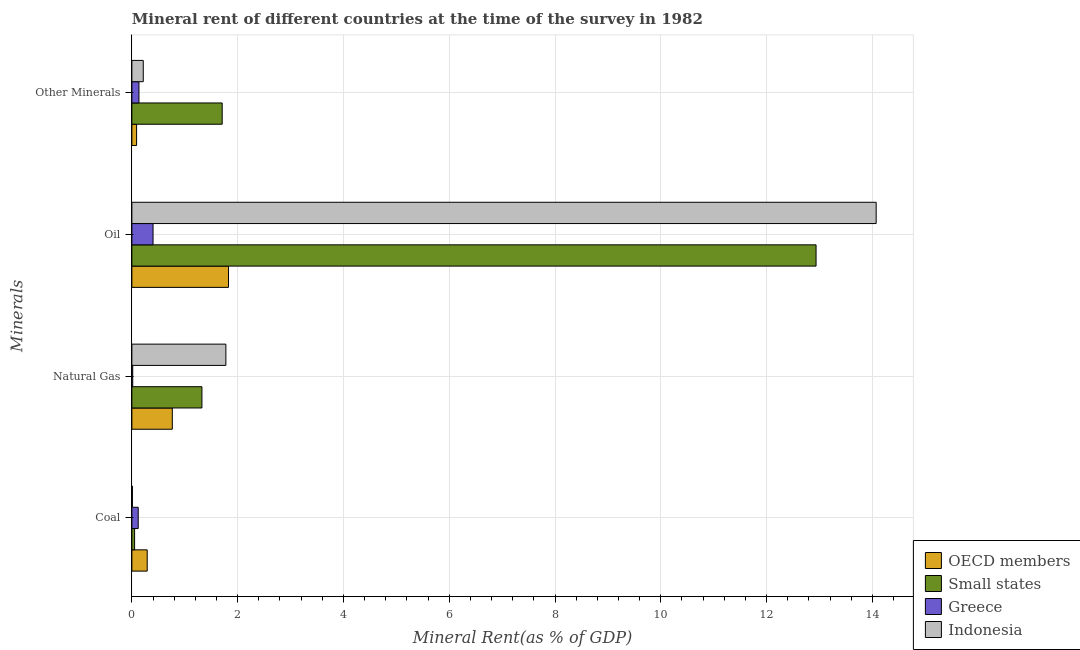How many different coloured bars are there?
Offer a very short reply. 4. Are the number of bars on each tick of the Y-axis equal?
Give a very brief answer. Yes. What is the label of the 4th group of bars from the top?
Your answer should be very brief. Coal. What is the oil rent in Indonesia?
Your response must be concise. 14.07. Across all countries, what is the maximum natural gas rent?
Offer a terse response. 1.78. Across all countries, what is the minimum oil rent?
Keep it short and to the point. 0.4. In which country was the oil rent maximum?
Offer a very short reply. Indonesia. In which country was the natural gas rent minimum?
Ensure brevity in your answer.  Greece. What is the total oil rent in the graph?
Keep it short and to the point. 29.23. What is the difference between the natural gas rent in Greece and that in Indonesia?
Offer a very short reply. -1.76. What is the difference between the oil rent in Indonesia and the  rent of other minerals in Small states?
Provide a succinct answer. 12.36. What is the average oil rent per country?
Provide a short and direct response. 7.31. What is the difference between the oil rent and  rent of other minerals in OECD members?
Make the answer very short. 1.74. What is the ratio of the coal rent in Indonesia to that in OECD members?
Your answer should be very brief. 0.04. Is the oil rent in Indonesia less than that in OECD members?
Ensure brevity in your answer.  No. What is the difference between the highest and the second highest natural gas rent?
Offer a terse response. 0.45. What is the difference between the highest and the lowest coal rent?
Provide a short and direct response. 0.28. What does the 3rd bar from the top in Other Minerals represents?
Your answer should be compact. Small states. What does the 3rd bar from the bottom in Other Minerals represents?
Offer a terse response. Greece. Is it the case that in every country, the sum of the coal rent and natural gas rent is greater than the oil rent?
Give a very brief answer. No. How many countries are there in the graph?
Your answer should be very brief. 4. Does the graph contain grids?
Offer a very short reply. Yes. Where does the legend appear in the graph?
Offer a terse response. Bottom right. How many legend labels are there?
Give a very brief answer. 4. How are the legend labels stacked?
Make the answer very short. Vertical. What is the title of the graph?
Offer a very short reply. Mineral rent of different countries at the time of the survey in 1982. What is the label or title of the X-axis?
Make the answer very short. Mineral Rent(as % of GDP). What is the label or title of the Y-axis?
Your answer should be very brief. Minerals. What is the Mineral Rent(as % of GDP) in OECD members in Coal?
Your response must be concise. 0.29. What is the Mineral Rent(as % of GDP) of Small states in Coal?
Offer a terse response. 0.05. What is the Mineral Rent(as % of GDP) of Greece in Coal?
Provide a succinct answer. 0.12. What is the Mineral Rent(as % of GDP) of Indonesia in Coal?
Ensure brevity in your answer.  0.01. What is the Mineral Rent(as % of GDP) of OECD members in Natural Gas?
Your response must be concise. 0.76. What is the Mineral Rent(as % of GDP) in Small states in Natural Gas?
Make the answer very short. 1.32. What is the Mineral Rent(as % of GDP) of Greece in Natural Gas?
Your answer should be compact. 0.02. What is the Mineral Rent(as % of GDP) in Indonesia in Natural Gas?
Provide a short and direct response. 1.78. What is the Mineral Rent(as % of GDP) of OECD members in Oil?
Keep it short and to the point. 1.83. What is the Mineral Rent(as % of GDP) of Small states in Oil?
Offer a very short reply. 12.94. What is the Mineral Rent(as % of GDP) in Greece in Oil?
Your answer should be very brief. 0.4. What is the Mineral Rent(as % of GDP) in Indonesia in Oil?
Make the answer very short. 14.07. What is the Mineral Rent(as % of GDP) in OECD members in Other Minerals?
Provide a short and direct response. 0.09. What is the Mineral Rent(as % of GDP) in Small states in Other Minerals?
Ensure brevity in your answer.  1.71. What is the Mineral Rent(as % of GDP) in Greece in Other Minerals?
Your answer should be compact. 0.13. What is the Mineral Rent(as % of GDP) in Indonesia in Other Minerals?
Your answer should be very brief. 0.22. Across all Minerals, what is the maximum Mineral Rent(as % of GDP) of OECD members?
Ensure brevity in your answer.  1.83. Across all Minerals, what is the maximum Mineral Rent(as % of GDP) in Small states?
Give a very brief answer. 12.94. Across all Minerals, what is the maximum Mineral Rent(as % of GDP) in Greece?
Offer a terse response. 0.4. Across all Minerals, what is the maximum Mineral Rent(as % of GDP) of Indonesia?
Provide a succinct answer. 14.07. Across all Minerals, what is the minimum Mineral Rent(as % of GDP) of OECD members?
Offer a terse response. 0.09. Across all Minerals, what is the minimum Mineral Rent(as % of GDP) of Small states?
Make the answer very short. 0.05. Across all Minerals, what is the minimum Mineral Rent(as % of GDP) in Greece?
Give a very brief answer. 0.02. Across all Minerals, what is the minimum Mineral Rent(as % of GDP) in Indonesia?
Make the answer very short. 0.01. What is the total Mineral Rent(as % of GDP) in OECD members in the graph?
Provide a succinct answer. 2.97. What is the total Mineral Rent(as % of GDP) of Small states in the graph?
Ensure brevity in your answer.  16.02. What is the total Mineral Rent(as % of GDP) of Greece in the graph?
Provide a succinct answer. 0.67. What is the total Mineral Rent(as % of GDP) of Indonesia in the graph?
Provide a short and direct response. 16.07. What is the difference between the Mineral Rent(as % of GDP) in OECD members in Coal and that in Natural Gas?
Give a very brief answer. -0.47. What is the difference between the Mineral Rent(as % of GDP) of Small states in Coal and that in Natural Gas?
Provide a short and direct response. -1.27. What is the difference between the Mineral Rent(as % of GDP) of Greece in Coal and that in Natural Gas?
Offer a very short reply. 0.1. What is the difference between the Mineral Rent(as % of GDP) in Indonesia in Coal and that in Natural Gas?
Offer a terse response. -1.77. What is the difference between the Mineral Rent(as % of GDP) in OECD members in Coal and that in Oil?
Ensure brevity in your answer.  -1.54. What is the difference between the Mineral Rent(as % of GDP) of Small states in Coal and that in Oil?
Make the answer very short. -12.88. What is the difference between the Mineral Rent(as % of GDP) in Greece in Coal and that in Oil?
Your answer should be compact. -0.28. What is the difference between the Mineral Rent(as % of GDP) in Indonesia in Coal and that in Oil?
Your answer should be compact. -14.06. What is the difference between the Mineral Rent(as % of GDP) of OECD members in Coal and that in Other Minerals?
Give a very brief answer. 0.2. What is the difference between the Mineral Rent(as % of GDP) of Small states in Coal and that in Other Minerals?
Ensure brevity in your answer.  -1.66. What is the difference between the Mineral Rent(as % of GDP) in Greece in Coal and that in Other Minerals?
Keep it short and to the point. -0.01. What is the difference between the Mineral Rent(as % of GDP) in Indonesia in Coal and that in Other Minerals?
Make the answer very short. -0.2. What is the difference between the Mineral Rent(as % of GDP) of OECD members in Natural Gas and that in Oil?
Provide a short and direct response. -1.06. What is the difference between the Mineral Rent(as % of GDP) in Small states in Natural Gas and that in Oil?
Ensure brevity in your answer.  -11.61. What is the difference between the Mineral Rent(as % of GDP) of Greece in Natural Gas and that in Oil?
Make the answer very short. -0.38. What is the difference between the Mineral Rent(as % of GDP) in Indonesia in Natural Gas and that in Oil?
Your answer should be very brief. -12.29. What is the difference between the Mineral Rent(as % of GDP) of OECD members in Natural Gas and that in Other Minerals?
Your response must be concise. 0.68. What is the difference between the Mineral Rent(as % of GDP) in Small states in Natural Gas and that in Other Minerals?
Provide a short and direct response. -0.38. What is the difference between the Mineral Rent(as % of GDP) in Greece in Natural Gas and that in Other Minerals?
Give a very brief answer. -0.12. What is the difference between the Mineral Rent(as % of GDP) of Indonesia in Natural Gas and that in Other Minerals?
Give a very brief answer. 1.56. What is the difference between the Mineral Rent(as % of GDP) of OECD members in Oil and that in Other Minerals?
Your response must be concise. 1.74. What is the difference between the Mineral Rent(as % of GDP) of Small states in Oil and that in Other Minerals?
Ensure brevity in your answer.  11.23. What is the difference between the Mineral Rent(as % of GDP) of Greece in Oil and that in Other Minerals?
Give a very brief answer. 0.27. What is the difference between the Mineral Rent(as % of GDP) of Indonesia in Oil and that in Other Minerals?
Make the answer very short. 13.86. What is the difference between the Mineral Rent(as % of GDP) in OECD members in Coal and the Mineral Rent(as % of GDP) in Small states in Natural Gas?
Your response must be concise. -1.03. What is the difference between the Mineral Rent(as % of GDP) in OECD members in Coal and the Mineral Rent(as % of GDP) in Greece in Natural Gas?
Keep it short and to the point. 0.27. What is the difference between the Mineral Rent(as % of GDP) of OECD members in Coal and the Mineral Rent(as % of GDP) of Indonesia in Natural Gas?
Offer a very short reply. -1.49. What is the difference between the Mineral Rent(as % of GDP) of Small states in Coal and the Mineral Rent(as % of GDP) of Greece in Natural Gas?
Make the answer very short. 0.04. What is the difference between the Mineral Rent(as % of GDP) in Small states in Coal and the Mineral Rent(as % of GDP) in Indonesia in Natural Gas?
Your answer should be compact. -1.73. What is the difference between the Mineral Rent(as % of GDP) in Greece in Coal and the Mineral Rent(as % of GDP) in Indonesia in Natural Gas?
Your answer should be compact. -1.66. What is the difference between the Mineral Rent(as % of GDP) in OECD members in Coal and the Mineral Rent(as % of GDP) in Small states in Oil?
Keep it short and to the point. -12.65. What is the difference between the Mineral Rent(as % of GDP) of OECD members in Coal and the Mineral Rent(as % of GDP) of Greece in Oil?
Your response must be concise. -0.11. What is the difference between the Mineral Rent(as % of GDP) of OECD members in Coal and the Mineral Rent(as % of GDP) of Indonesia in Oil?
Make the answer very short. -13.78. What is the difference between the Mineral Rent(as % of GDP) in Small states in Coal and the Mineral Rent(as % of GDP) in Greece in Oil?
Keep it short and to the point. -0.35. What is the difference between the Mineral Rent(as % of GDP) in Small states in Coal and the Mineral Rent(as % of GDP) in Indonesia in Oil?
Your response must be concise. -14.02. What is the difference between the Mineral Rent(as % of GDP) of Greece in Coal and the Mineral Rent(as % of GDP) of Indonesia in Oil?
Keep it short and to the point. -13.95. What is the difference between the Mineral Rent(as % of GDP) of OECD members in Coal and the Mineral Rent(as % of GDP) of Small states in Other Minerals?
Your answer should be very brief. -1.42. What is the difference between the Mineral Rent(as % of GDP) in OECD members in Coal and the Mineral Rent(as % of GDP) in Greece in Other Minerals?
Offer a terse response. 0.16. What is the difference between the Mineral Rent(as % of GDP) of OECD members in Coal and the Mineral Rent(as % of GDP) of Indonesia in Other Minerals?
Offer a terse response. 0.07. What is the difference between the Mineral Rent(as % of GDP) in Small states in Coal and the Mineral Rent(as % of GDP) in Greece in Other Minerals?
Provide a short and direct response. -0.08. What is the difference between the Mineral Rent(as % of GDP) of Small states in Coal and the Mineral Rent(as % of GDP) of Indonesia in Other Minerals?
Ensure brevity in your answer.  -0.16. What is the difference between the Mineral Rent(as % of GDP) of Greece in Coal and the Mineral Rent(as % of GDP) of Indonesia in Other Minerals?
Provide a succinct answer. -0.1. What is the difference between the Mineral Rent(as % of GDP) in OECD members in Natural Gas and the Mineral Rent(as % of GDP) in Small states in Oil?
Your response must be concise. -12.17. What is the difference between the Mineral Rent(as % of GDP) of OECD members in Natural Gas and the Mineral Rent(as % of GDP) of Greece in Oil?
Give a very brief answer. 0.36. What is the difference between the Mineral Rent(as % of GDP) in OECD members in Natural Gas and the Mineral Rent(as % of GDP) in Indonesia in Oil?
Provide a short and direct response. -13.31. What is the difference between the Mineral Rent(as % of GDP) of Small states in Natural Gas and the Mineral Rent(as % of GDP) of Greece in Oil?
Offer a very short reply. 0.92. What is the difference between the Mineral Rent(as % of GDP) of Small states in Natural Gas and the Mineral Rent(as % of GDP) of Indonesia in Oil?
Ensure brevity in your answer.  -12.75. What is the difference between the Mineral Rent(as % of GDP) of Greece in Natural Gas and the Mineral Rent(as % of GDP) of Indonesia in Oil?
Your answer should be very brief. -14.06. What is the difference between the Mineral Rent(as % of GDP) of OECD members in Natural Gas and the Mineral Rent(as % of GDP) of Small states in Other Minerals?
Provide a short and direct response. -0.94. What is the difference between the Mineral Rent(as % of GDP) in OECD members in Natural Gas and the Mineral Rent(as % of GDP) in Greece in Other Minerals?
Give a very brief answer. 0.63. What is the difference between the Mineral Rent(as % of GDP) of OECD members in Natural Gas and the Mineral Rent(as % of GDP) of Indonesia in Other Minerals?
Your answer should be very brief. 0.55. What is the difference between the Mineral Rent(as % of GDP) of Small states in Natural Gas and the Mineral Rent(as % of GDP) of Greece in Other Minerals?
Give a very brief answer. 1.19. What is the difference between the Mineral Rent(as % of GDP) of Small states in Natural Gas and the Mineral Rent(as % of GDP) of Indonesia in Other Minerals?
Your response must be concise. 1.11. What is the difference between the Mineral Rent(as % of GDP) in Greece in Natural Gas and the Mineral Rent(as % of GDP) in Indonesia in Other Minerals?
Offer a terse response. -0.2. What is the difference between the Mineral Rent(as % of GDP) of OECD members in Oil and the Mineral Rent(as % of GDP) of Small states in Other Minerals?
Ensure brevity in your answer.  0.12. What is the difference between the Mineral Rent(as % of GDP) in OECD members in Oil and the Mineral Rent(as % of GDP) in Greece in Other Minerals?
Provide a short and direct response. 1.69. What is the difference between the Mineral Rent(as % of GDP) in OECD members in Oil and the Mineral Rent(as % of GDP) in Indonesia in Other Minerals?
Provide a short and direct response. 1.61. What is the difference between the Mineral Rent(as % of GDP) in Small states in Oil and the Mineral Rent(as % of GDP) in Greece in Other Minerals?
Ensure brevity in your answer.  12.8. What is the difference between the Mineral Rent(as % of GDP) in Small states in Oil and the Mineral Rent(as % of GDP) in Indonesia in Other Minerals?
Make the answer very short. 12.72. What is the difference between the Mineral Rent(as % of GDP) in Greece in Oil and the Mineral Rent(as % of GDP) in Indonesia in Other Minerals?
Provide a short and direct response. 0.18. What is the average Mineral Rent(as % of GDP) of OECD members per Minerals?
Make the answer very short. 0.74. What is the average Mineral Rent(as % of GDP) of Small states per Minerals?
Your response must be concise. 4. What is the average Mineral Rent(as % of GDP) of Greece per Minerals?
Your response must be concise. 0.17. What is the average Mineral Rent(as % of GDP) of Indonesia per Minerals?
Offer a very short reply. 4.02. What is the difference between the Mineral Rent(as % of GDP) of OECD members and Mineral Rent(as % of GDP) of Small states in Coal?
Give a very brief answer. 0.24. What is the difference between the Mineral Rent(as % of GDP) in OECD members and Mineral Rent(as % of GDP) in Greece in Coal?
Your answer should be compact. 0.17. What is the difference between the Mineral Rent(as % of GDP) of OECD members and Mineral Rent(as % of GDP) of Indonesia in Coal?
Provide a succinct answer. 0.28. What is the difference between the Mineral Rent(as % of GDP) in Small states and Mineral Rent(as % of GDP) in Greece in Coal?
Your response must be concise. -0.07. What is the difference between the Mineral Rent(as % of GDP) in Small states and Mineral Rent(as % of GDP) in Indonesia in Coal?
Your response must be concise. 0.04. What is the difference between the Mineral Rent(as % of GDP) in Greece and Mineral Rent(as % of GDP) in Indonesia in Coal?
Offer a terse response. 0.11. What is the difference between the Mineral Rent(as % of GDP) of OECD members and Mineral Rent(as % of GDP) of Small states in Natural Gas?
Your answer should be compact. -0.56. What is the difference between the Mineral Rent(as % of GDP) in OECD members and Mineral Rent(as % of GDP) in Greece in Natural Gas?
Offer a very short reply. 0.75. What is the difference between the Mineral Rent(as % of GDP) in OECD members and Mineral Rent(as % of GDP) in Indonesia in Natural Gas?
Keep it short and to the point. -1.01. What is the difference between the Mineral Rent(as % of GDP) in Small states and Mineral Rent(as % of GDP) in Greece in Natural Gas?
Provide a succinct answer. 1.31. What is the difference between the Mineral Rent(as % of GDP) of Small states and Mineral Rent(as % of GDP) of Indonesia in Natural Gas?
Provide a short and direct response. -0.45. What is the difference between the Mineral Rent(as % of GDP) of Greece and Mineral Rent(as % of GDP) of Indonesia in Natural Gas?
Offer a very short reply. -1.76. What is the difference between the Mineral Rent(as % of GDP) of OECD members and Mineral Rent(as % of GDP) of Small states in Oil?
Ensure brevity in your answer.  -11.11. What is the difference between the Mineral Rent(as % of GDP) in OECD members and Mineral Rent(as % of GDP) in Greece in Oil?
Keep it short and to the point. 1.43. What is the difference between the Mineral Rent(as % of GDP) of OECD members and Mineral Rent(as % of GDP) of Indonesia in Oil?
Your response must be concise. -12.24. What is the difference between the Mineral Rent(as % of GDP) in Small states and Mineral Rent(as % of GDP) in Greece in Oil?
Your answer should be very brief. 12.53. What is the difference between the Mineral Rent(as % of GDP) in Small states and Mineral Rent(as % of GDP) in Indonesia in Oil?
Your response must be concise. -1.14. What is the difference between the Mineral Rent(as % of GDP) in Greece and Mineral Rent(as % of GDP) in Indonesia in Oil?
Keep it short and to the point. -13.67. What is the difference between the Mineral Rent(as % of GDP) in OECD members and Mineral Rent(as % of GDP) in Small states in Other Minerals?
Offer a terse response. -1.62. What is the difference between the Mineral Rent(as % of GDP) of OECD members and Mineral Rent(as % of GDP) of Greece in Other Minerals?
Offer a very short reply. -0.04. What is the difference between the Mineral Rent(as % of GDP) in OECD members and Mineral Rent(as % of GDP) in Indonesia in Other Minerals?
Your response must be concise. -0.13. What is the difference between the Mineral Rent(as % of GDP) of Small states and Mineral Rent(as % of GDP) of Greece in Other Minerals?
Keep it short and to the point. 1.57. What is the difference between the Mineral Rent(as % of GDP) of Small states and Mineral Rent(as % of GDP) of Indonesia in Other Minerals?
Make the answer very short. 1.49. What is the difference between the Mineral Rent(as % of GDP) of Greece and Mineral Rent(as % of GDP) of Indonesia in Other Minerals?
Offer a terse response. -0.08. What is the ratio of the Mineral Rent(as % of GDP) of OECD members in Coal to that in Natural Gas?
Your answer should be very brief. 0.38. What is the ratio of the Mineral Rent(as % of GDP) of Small states in Coal to that in Natural Gas?
Your response must be concise. 0.04. What is the ratio of the Mineral Rent(as % of GDP) of Greece in Coal to that in Natural Gas?
Your answer should be very brief. 7.58. What is the ratio of the Mineral Rent(as % of GDP) of Indonesia in Coal to that in Natural Gas?
Keep it short and to the point. 0.01. What is the ratio of the Mineral Rent(as % of GDP) in OECD members in Coal to that in Oil?
Your response must be concise. 0.16. What is the ratio of the Mineral Rent(as % of GDP) in Small states in Coal to that in Oil?
Offer a terse response. 0. What is the ratio of the Mineral Rent(as % of GDP) in Greece in Coal to that in Oil?
Give a very brief answer. 0.3. What is the ratio of the Mineral Rent(as % of GDP) in Indonesia in Coal to that in Oil?
Ensure brevity in your answer.  0. What is the ratio of the Mineral Rent(as % of GDP) in OECD members in Coal to that in Other Minerals?
Offer a very short reply. 3.25. What is the ratio of the Mineral Rent(as % of GDP) of Small states in Coal to that in Other Minerals?
Make the answer very short. 0.03. What is the ratio of the Mineral Rent(as % of GDP) of Greece in Coal to that in Other Minerals?
Keep it short and to the point. 0.9. What is the ratio of the Mineral Rent(as % of GDP) of Indonesia in Coal to that in Other Minerals?
Provide a short and direct response. 0.05. What is the ratio of the Mineral Rent(as % of GDP) in OECD members in Natural Gas to that in Oil?
Your answer should be very brief. 0.42. What is the ratio of the Mineral Rent(as % of GDP) of Small states in Natural Gas to that in Oil?
Give a very brief answer. 0.1. What is the ratio of the Mineral Rent(as % of GDP) of Greece in Natural Gas to that in Oil?
Provide a short and direct response. 0.04. What is the ratio of the Mineral Rent(as % of GDP) in Indonesia in Natural Gas to that in Oil?
Your response must be concise. 0.13. What is the ratio of the Mineral Rent(as % of GDP) of OECD members in Natural Gas to that in Other Minerals?
Give a very brief answer. 8.58. What is the ratio of the Mineral Rent(as % of GDP) of Small states in Natural Gas to that in Other Minerals?
Offer a terse response. 0.78. What is the ratio of the Mineral Rent(as % of GDP) in Greece in Natural Gas to that in Other Minerals?
Give a very brief answer. 0.12. What is the ratio of the Mineral Rent(as % of GDP) of Indonesia in Natural Gas to that in Other Minerals?
Provide a short and direct response. 8.25. What is the ratio of the Mineral Rent(as % of GDP) in OECD members in Oil to that in Other Minerals?
Offer a terse response. 20.49. What is the ratio of the Mineral Rent(as % of GDP) of Small states in Oil to that in Other Minerals?
Your answer should be very brief. 7.58. What is the ratio of the Mineral Rent(as % of GDP) of Greece in Oil to that in Other Minerals?
Offer a very short reply. 2.99. What is the ratio of the Mineral Rent(as % of GDP) of Indonesia in Oil to that in Other Minerals?
Make the answer very short. 65.34. What is the difference between the highest and the second highest Mineral Rent(as % of GDP) in OECD members?
Your response must be concise. 1.06. What is the difference between the highest and the second highest Mineral Rent(as % of GDP) of Small states?
Offer a very short reply. 11.23. What is the difference between the highest and the second highest Mineral Rent(as % of GDP) of Greece?
Provide a short and direct response. 0.27. What is the difference between the highest and the second highest Mineral Rent(as % of GDP) of Indonesia?
Make the answer very short. 12.29. What is the difference between the highest and the lowest Mineral Rent(as % of GDP) in OECD members?
Provide a succinct answer. 1.74. What is the difference between the highest and the lowest Mineral Rent(as % of GDP) of Small states?
Offer a terse response. 12.88. What is the difference between the highest and the lowest Mineral Rent(as % of GDP) in Greece?
Your answer should be very brief. 0.38. What is the difference between the highest and the lowest Mineral Rent(as % of GDP) of Indonesia?
Your answer should be very brief. 14.06. 